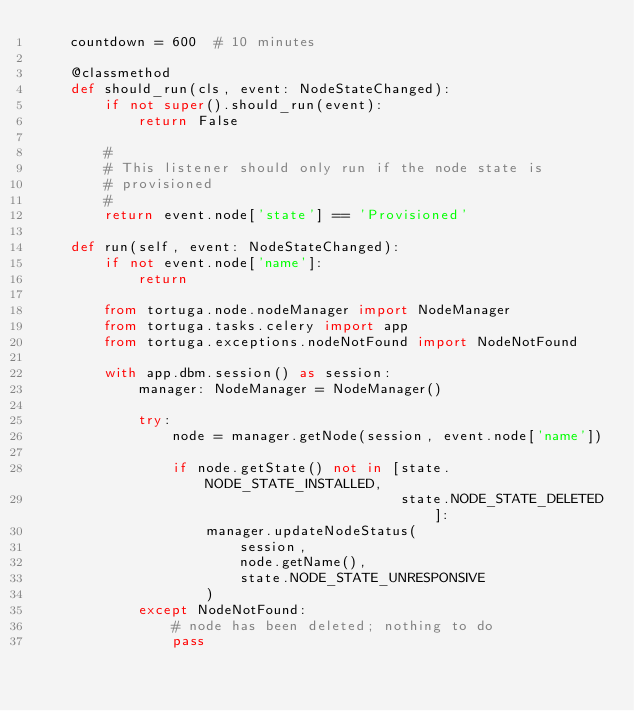Convert code to text. <code><loc_0><loc_0><loc_500><loc_500><_Python_>    countdown = 600  # 10 minutes

    @classmethod
    def should_run(cls, event: NodeStateChanged):
        if not super().should_run(event):
            return False

        #
        # This listener should only run if the node state is
        # provisioned
        #
        return event.node['state'] == 'Provisioned'

    def run(self, event: NodeStateChanged):
        if not event.node['name']:
            return

        from tortuga.node.nodeManager import NodeManager
        from tortuga.tasks.celery import app
        from tortuga.exceptions.nodeNotFound import NodeNotFound

        with app.dbm.session() as session:
            manager: NodeManager = NodeManager()

            try:
                node = manager.getNode(session, event.node['name'])

                if node.getState() not in [state.NODE_STATE_INSTALLED,
                                           state.NODE_STATE_DELETED]:
                    manager.updateNodeStatus(
                        session,
                        node.getName(),
                        state.NODE_STATE_UNRESPONSIVE
                    )
            except NodeNotFound:
                # node has been deleted; nothing to do
                pass
</code> 